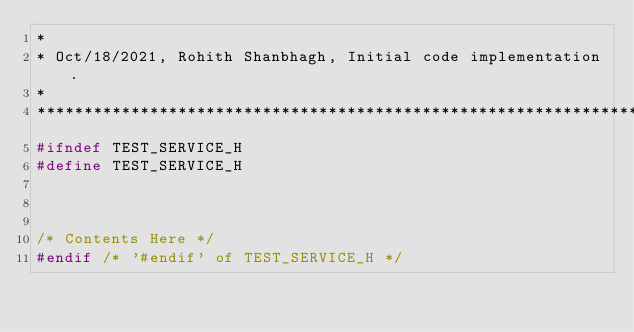Convert code to text. <code><loc_0><loc_0><loc_500><loc_500><_C_>*
* Oct/18/2021, Rohith Shanbhagh, Initial code implementation.
*
******************************************************************************/
#ifndef TEST_SERVICE_H
#define TEST_SERVICE_H



/* Contents Here */
#endif /* '#endif' of TEST_SERVICE_H */
</code> 